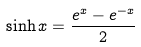<formula> <loc_0><loc_0><loc_500><loc_500>\sinh x = \frac { e ^ { x } - e ^ { - x } } { 2 }</formula> 